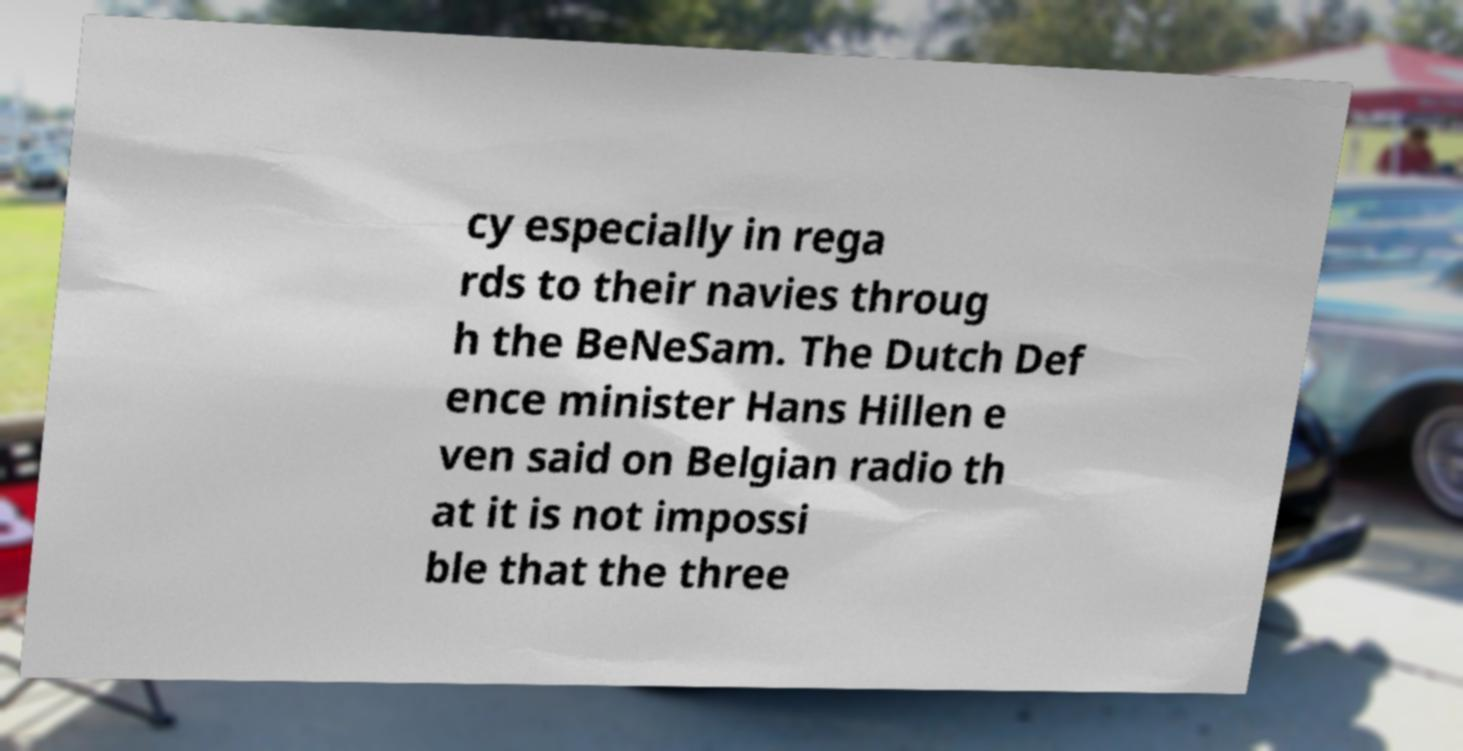Can you read and provide the text displayed in the image?This photo seems to have some interesting text. Can you extract and type it out for me? cy especially in rega rds to their navies throug h the BeNeSam. The Dutch Def ence minister Hans Hillen e ven said on Belgian radio th at it is not impossi ble that the three 